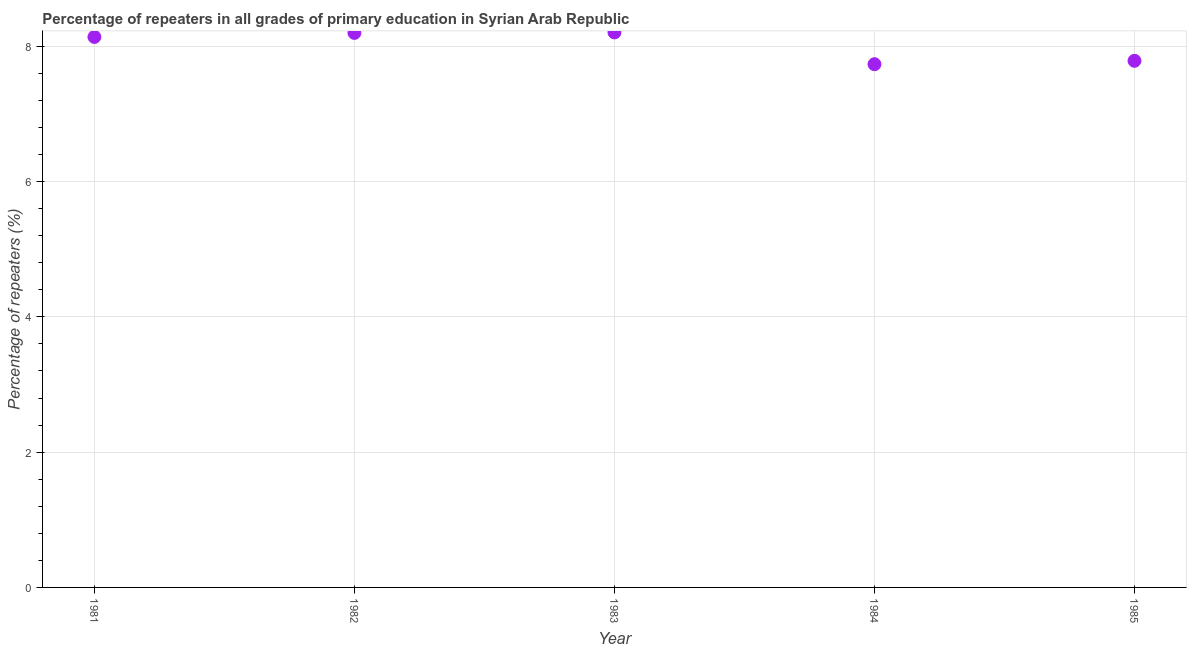What is the percentage of repeaters in primary education in 1984?
Ensure brevity in your answer.  7.74. Across all years, what is the maximum percentage of repeaters in primary education?
Provide a short and direct response. 8.21. Across all years, what is the minimum percentage of repeaters in primary education?
Offer a terse response. 7.74. What is the sum of the percentage of repeaters in primary education?
Provide a succinct answer. 40.06. What is the difference between the percentage of repeaters in primary education in 1981 and 1983?
Ensure brevity in your answer.  -0.07. What is the average percentage of repeaters in primary education per year?
Keep it short and to the point. 8.01. What is the median percentage of repeaters in primary education?
Keep it short and to the point. 8.14. In how many years, is the percentage of repeaters in primary education greater than 2.8 %?
Ensure brevity in your answer.  5. What is the ratio of the percentage of repeaters in primary education in 1982 to that in 1983?
Make the answer very short. 1. Is the percentage of repeaters in primary education in 1982 less than that in 1985?
Offer a terse response. No. What is the difference between the highest and the second highest percentage of repeaters in primary education?
Your answer should be compact. 0.01. Is the sum of the percentage of repeaters in primary education in 1981 and 1982 greater than the maximum percentage of repeaters in primary education across all years?
Provide a short and direct response. Yes. What is the difference between the highest and the lowest percentage of repeaters in primary education?
Provide a succinct answer. 0.47. Does the percentage of repeaters in primary education monotonically increase over the years?
Provide a short and direct response. No. How many dotlines are there?
Provide a succinct answer. 1. How many years are there in the graph?
Make the answer very short. 5. Are the values on the major ticks of Y-axis written in scientific E-notation?
Provide a succinct answer. No. Does the graph contain any zero values?
Keep it short and to the point. No. What is the title of the graph?
Offer a terse response. Percentage of repeaters in all grades of primary education in Syrian Arab Republic. What is the label or title of the Y-axis?
Offer a terse response. Percentage of repeaters (%). What is the Percentage of repeaters (%) in 1981?
Your answer should be compact. 8.14. What is the Percentage of repeaters (%) in 1982?
Provide a short and direct response. 8.2. What is the Percentage of repeaters (%) in 1983?
Offer a very short reply. 8.21. What is the Percentage of repeaters (%) in 1984?
Make the answer very short. 7.74. What is the Percentage of repeaters (%) in 1985?
Offer a terse response. 7.79. What is the difference between the Percentage of repeaters (%) in 1981 and 1982?
Provide a succinct answer. -0.06. What is the difference between the Percentage of repeaters (%) in 1981 and 1983?
Keep it short and to the point. -0.07. What is the difference between the Percentage of repeaters (%) in 1981 and 1984?
Keep it short and to the point. 0.4. What is the difference between the Percentage of repeaters (%) in 1981 and 1985?
Keep it short and to the point. 0.35. What is the difference between the Percentage of repeaters (%) in 1982 and 1983?
Provide a succinct answer. -0.01. What is the difference between the Percentage of repeaters (%) in 1982 and 1984?
Provide a short and direct response. 0.46. What is the difference between the Percentage of repeaters (%) in 1982 and 1985?
Make the answer very short. 0.41. What is the difference between the Percentage of repeaters (%) in 1983 and 1984?
Give a very brief answer. 0.47. What is the difference between the Percentage of repeaters (%) in 1983 and 1985?
Your answer should be compact. 0.42. What is the difference between the Percentage of repeaters (%) in 1984 and 1985?
Ensure brevity in your answer.  -0.05. What is the ratio of the Percentage of repeaters (%) in 1981 to that in 1982?
Make the answer very short. 0.99. What is the ratio of the Percentage of repeaters (%) in 1981 to that in 1984?
Your answer should be very brief. 1.05. What is the ratio of the Percentage of repeaters (%) in 1981 to that in 1985?
Provide a succinct answer. 1.04. What is the ratio of the Percentage of repeaters (%) in 1982 to that in 1984?
Your answer should be very brief. 1.06. What is the ratio of the Percentage of repeaters (%) in 1982 to that in 1985?
Your answer should be compact. 1.05. What is the ratio of the Percentage of repeaters (%) in 1983 to that in 1984?
Offer a very short reply. 1.06. What is the ratio of the Percentage of repeaters (%) in 1983 to that in 1985?
Keep it short and to the point. 1.05. What is the ratio of the Percentage of repeaters (%) in 1984 to that in 1985?
Keep it short and to the point. 0.99. 